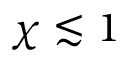Convert formula to latex. <formula><loc_0><loc_0><loc_500><loc_500>\chi \lesssim 1</formula> 